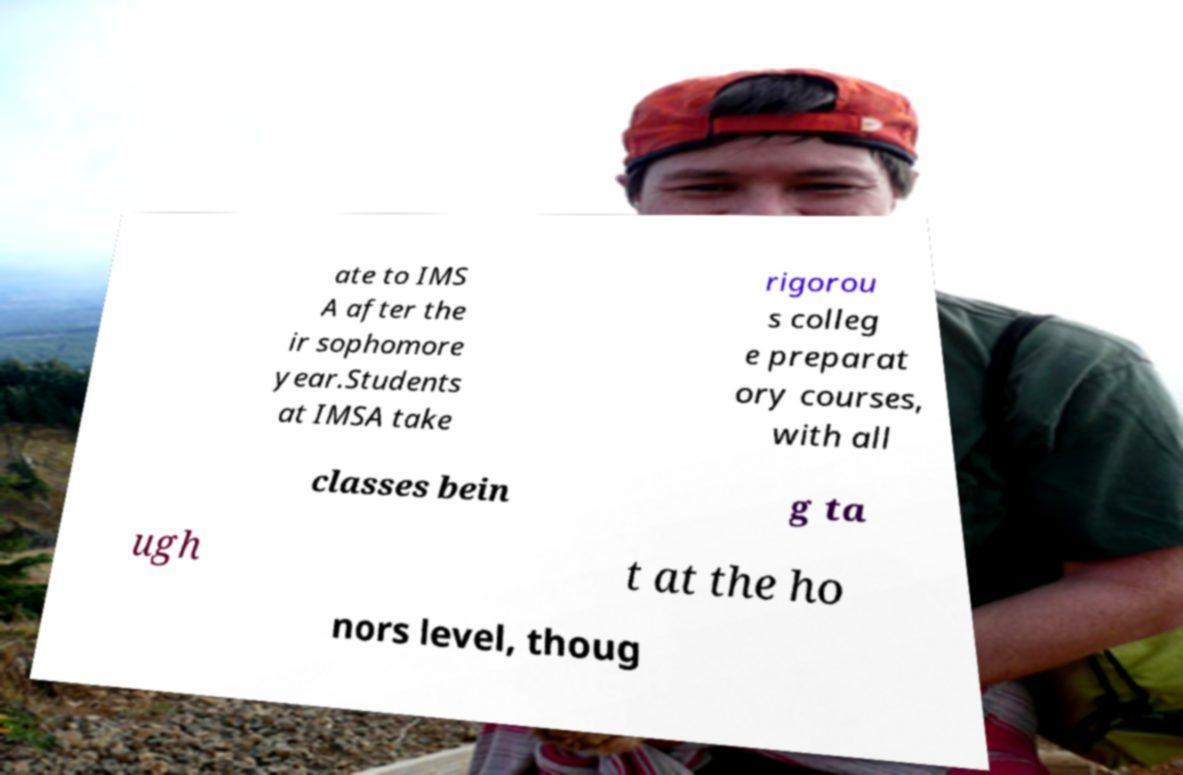Could you assist in decoding the text presented in this image and type it out clearly? ate to IMS A after the ir sophomore year.Students at IMSA take rigorou s colleg e preparat ory courses, with all classes bein g ta ugh t at the ho nors level, thoug 